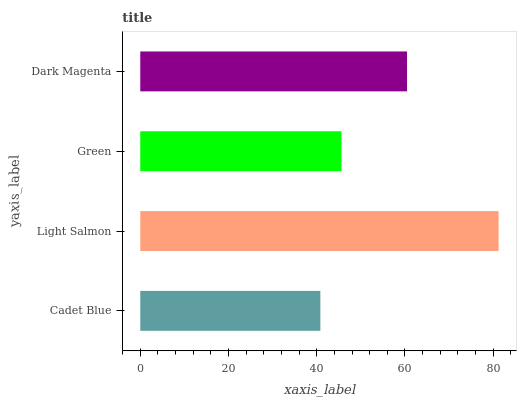Is Cadet Blue the minimum?
Answer yes or no. Yes. Is Light Salmon the maximum?
Answer yes or no. Yes. Is Green the minimum?
Answer yes or no. No. Is Green the maximum?
Answer yes or no. No. Is Light Salmon greater than Green?
Answer yes or no. Yes. Is Green less than Light Salmon?
Answer yes or no. Yes. Is Green greater than Light Salmon?
Answer yes or no. No. Is Light Salmon less than Green?
Answer yes or no. No. Is Dark Magenta the high median?
Answer yes or no. Yes. Is Green the low median?
Answer yes or no. Yes. Is Cadet Blue the high median?
Answer yes or no. No. Is Dark Magenta the low median?
Answer yes or no. No. 